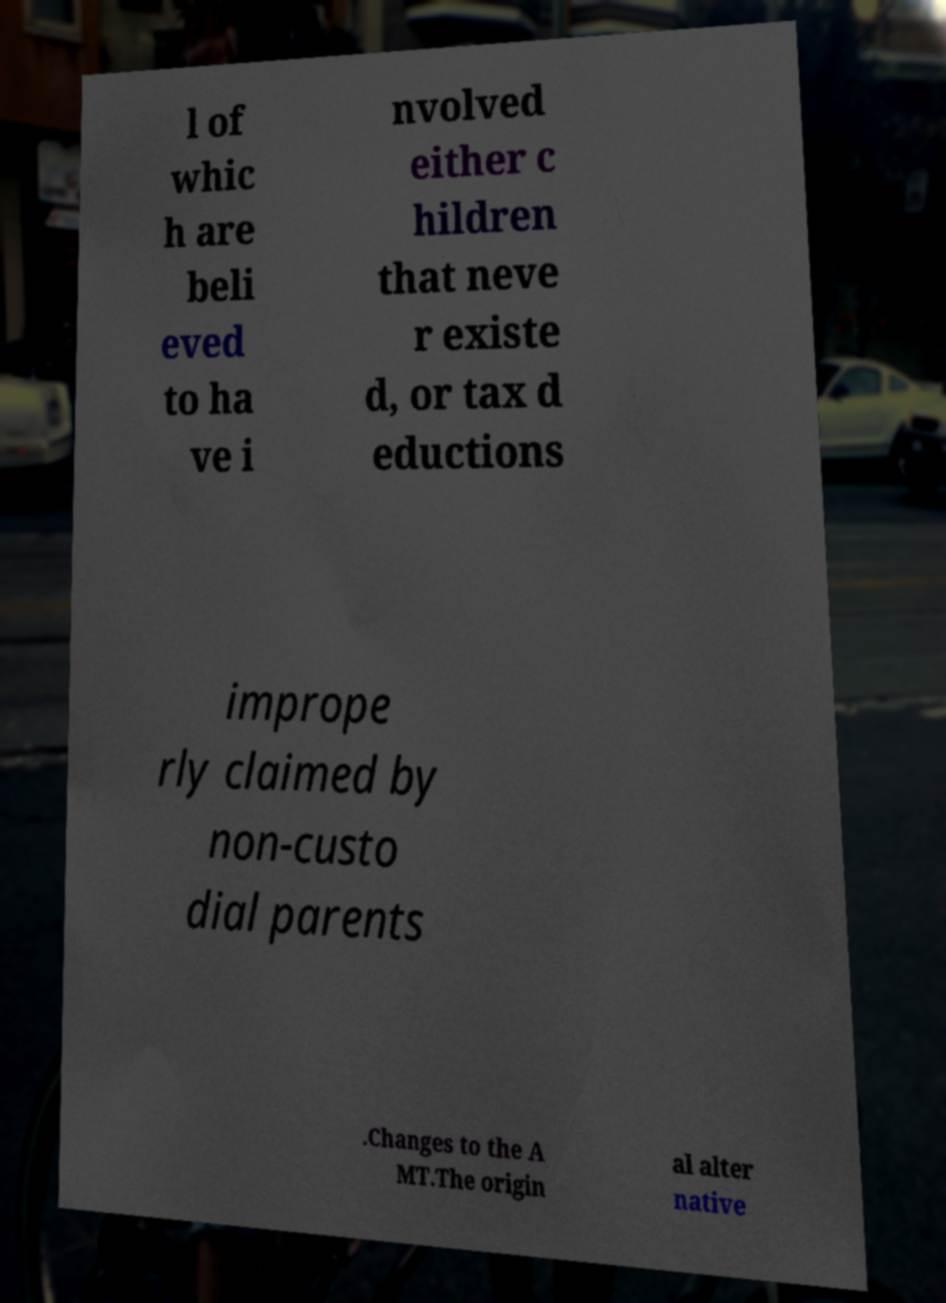Please read and relay the text visible in this image. What does it say? l of whic h are beli eved to ha ve i nvolved either c hildren that neve r existe d, or tax d eductions imprope rly claimed by non-custo dial parents .Changes to the A MT.The origin al alter native 